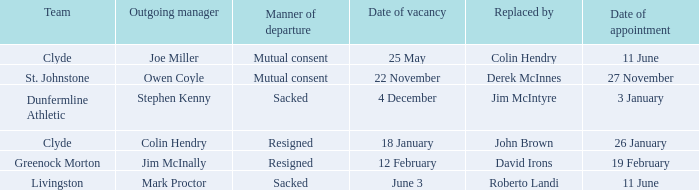Name the manner of departyre for 26 january date of appointment Resigned. 